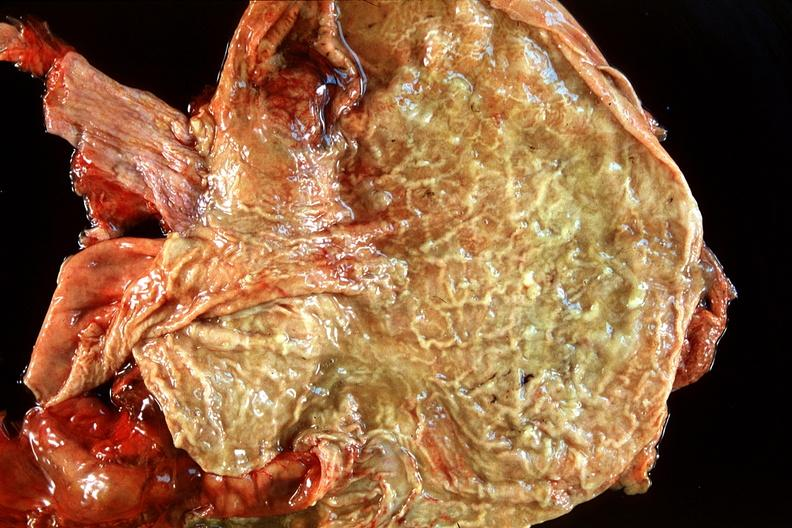where does this belong to?
Answer the question using a single word or phrase. Gastrointestinal system 